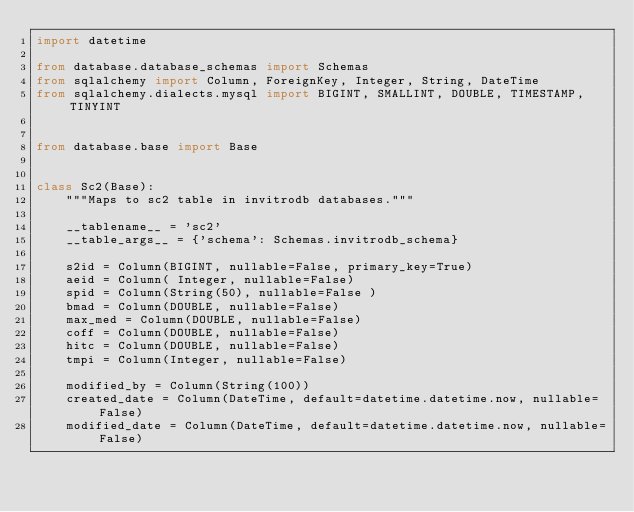Convert code to text. <code><loc_0><loc_0><loc_500><loc_500><_Python_>import datetime

from database.database_schemas import Schemas
from sqlalchemy import Column, ForeignKey, Integer, String, DateTime
from sqlalchemy.dialects.mysql import BIGINT, SMALLINT, DOUBLE, TIMESTAMP, TINYINT


from database.base import Base


class Sc2(Base):
    """Maps to sc2 table in invitrodb databases."""

    __tablename__ = 'sc2'
    __table_args__ = {'schema': Schemas.invitrodb_schema}

    s2id = Column(BIGINT, nullable=False, primary_key=True)
    aeid = Column( Integer, nullable=False)
    spid = Column(String(50), nullable=False )
    bmad = Column(DOUBLE, nullable=False)
    max_med = Column(DOUBLE, nullable=False)
    coff = Column(DOUBLE, nullable=False)
    hitc = Column(DOUBLE, nullable=False)
    tmpi = Column(Integer, nullable=False)

    modified_by = Column(String(100))
    created_date = Column(DateTime, default=datetime.datetime.now, nullable=False)
    modified_date = Column(DateTime, default=datetime.datetime.now, nullable=False)</code> 